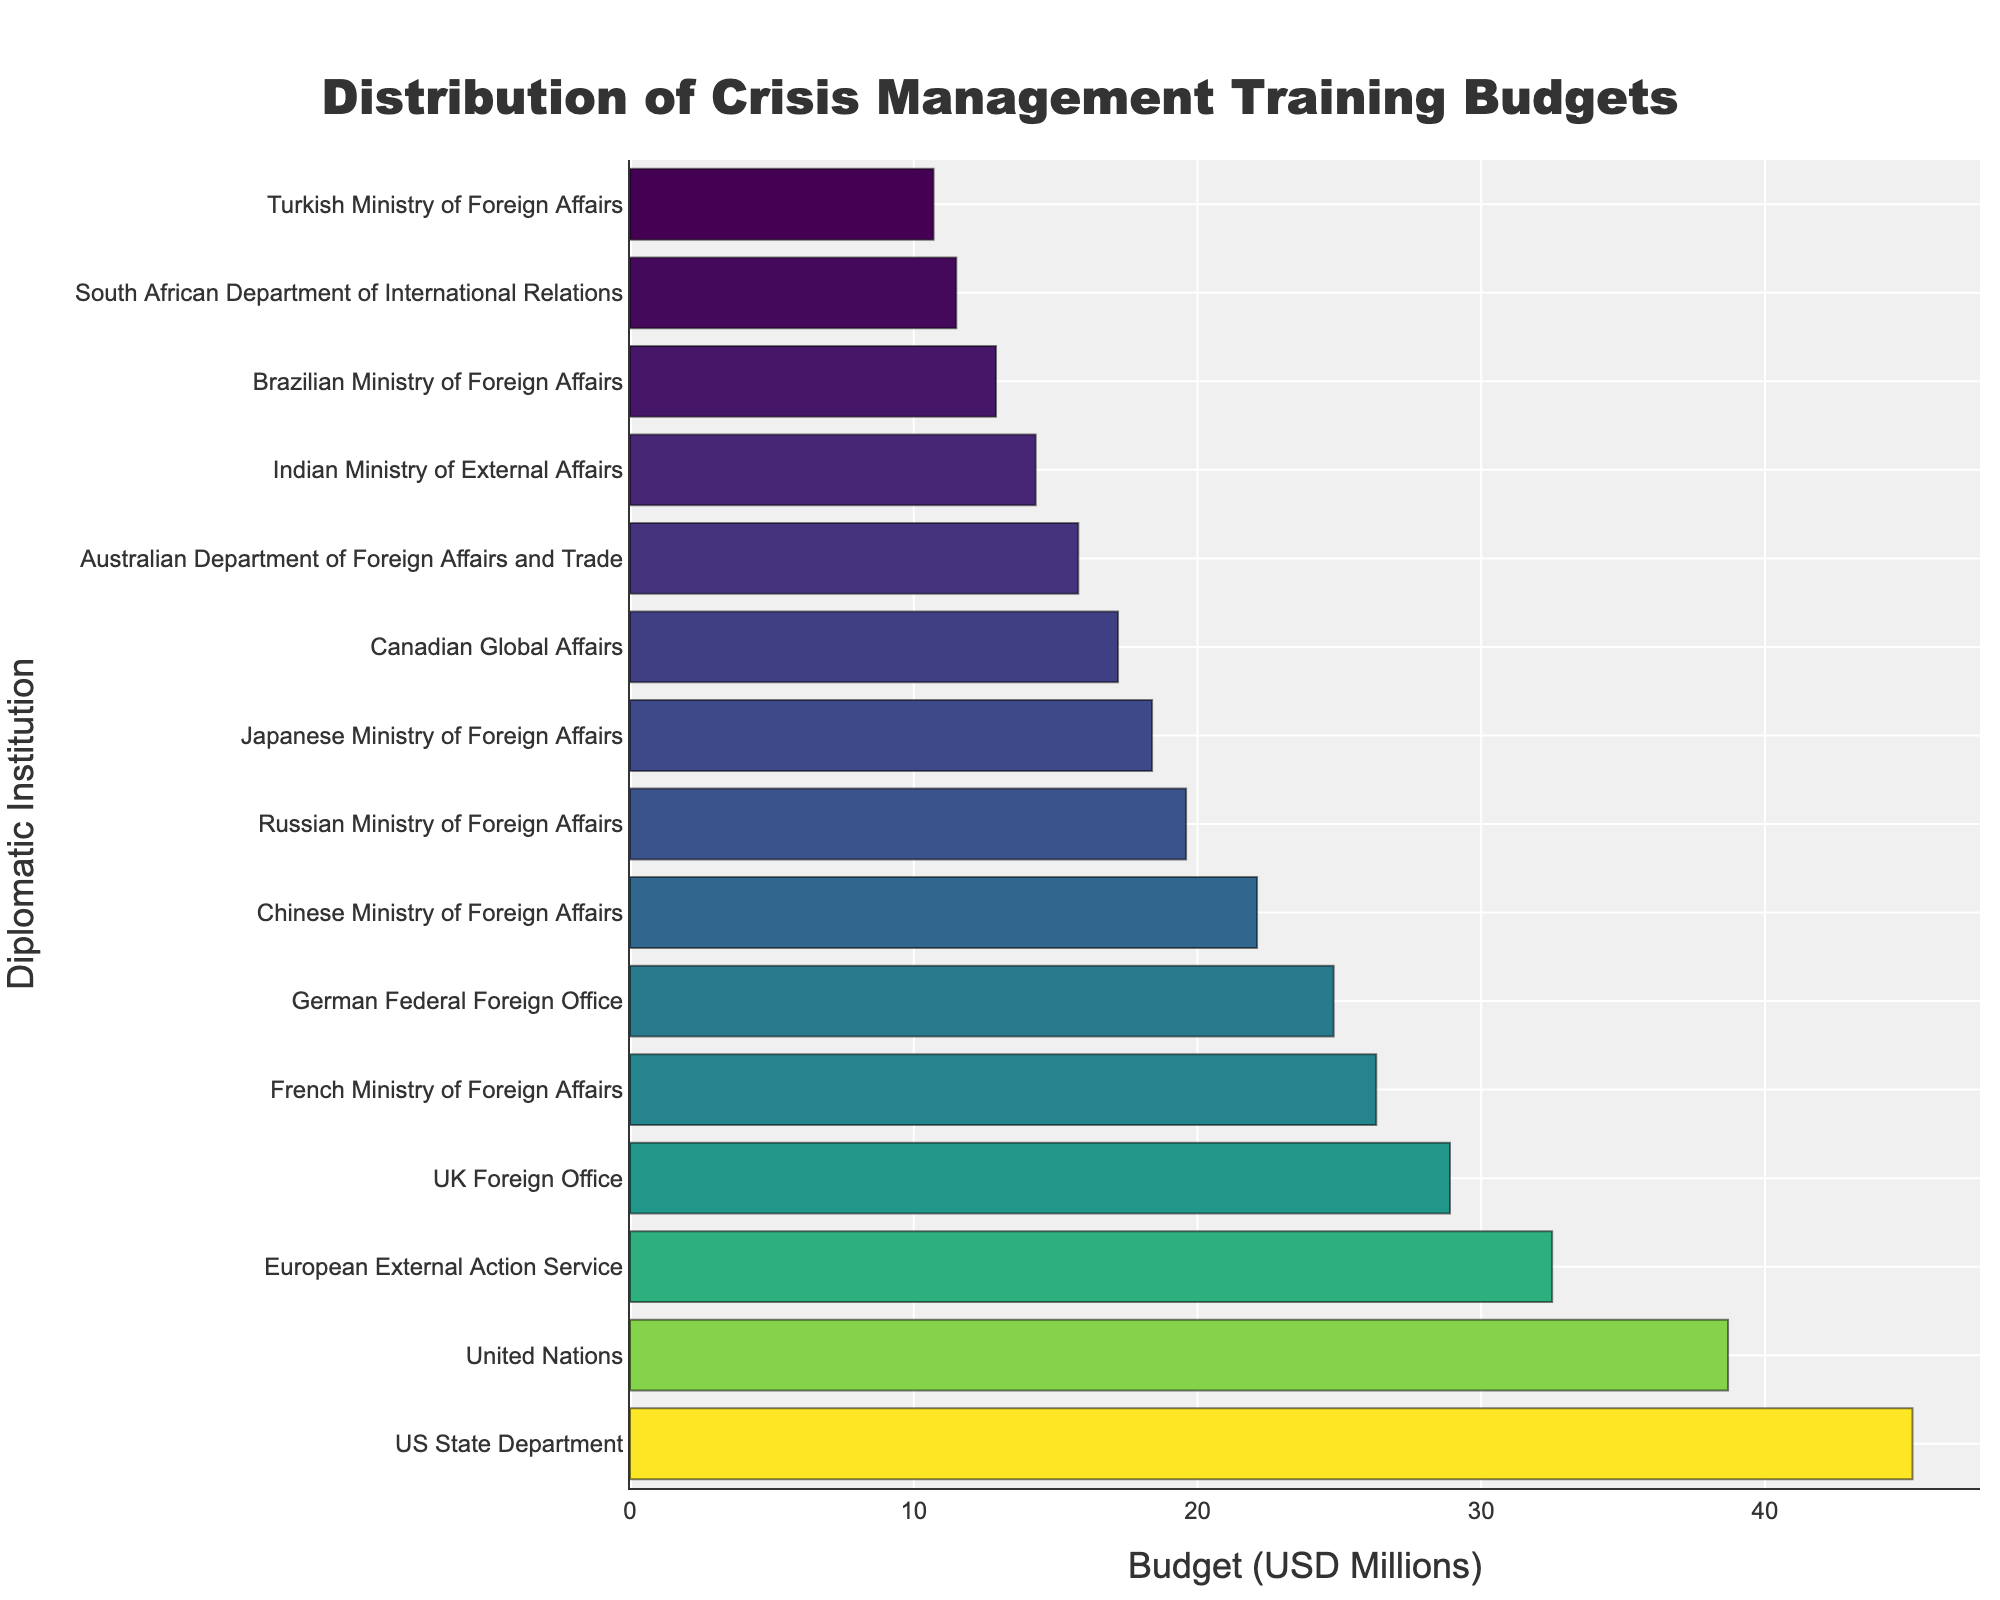What is the highest budget allocated to a diplomatic institution for crisis management training? By inspecting the lengths of the bars in the bar chart, the US State Department has the longest bar, which corresponds to the highest budget.
Answer: 45.2 million USD How much more is the budget of the US State Department compared to the UK Foreign Office? First, identify the budgets of both institutions: US State Department (45.2 million USD) and UK Foreign Office (28.9 million USD). Subtract the budget of the UK Foreign Office from the US State Department: 45.2 - 28.9 = 16.3 million USD.
Answer: 16.3 million USD Which institution has the lowest budget for crisis management training? By inspecting the lengths of the bars in the bar chart, the Turkish Ministry of Foreign Affairs has the shortest bar, corresponding to the lowest budget.
Answer: 10.7 million USD What is the total budget allocated for crisis management training across all institutions shown? Sum all budgets: 45.2 + 38.7 + 32.5 + 28.9 + 26.3 + 24.8 + 22.1 + 19.6 + 18.4 + 17.2 + 15.8 + 14.3 + 12.9 + 11.5 + 10.7 = 338.9 million USD
Answer: 338.9 million USD On average, how much budget is allocated per institution? First, calculate the total budget: 338.9 million USD. There are 15 institutions, so divide the total budget by the number of institutions: 338.9 / 15 ≈ 22.6 million USD.
Answer: 22.6 million USD Which institutions have a budget greater than 30 million USD? By inspecting the bar lengths and their corresponding values, the institutions with budgets greater than 30 million USD are the US State Department (45.2), United Nations (38.7), and European External Action Service (32.5).
Answer: US State Department, United Nations, European External Action Service How much is the combined budget of the Canadian Global Affairs and Australian Department of Foreign Affairs and Trade? Identify the budgets: Canadian Global Affairs (17.2 million USD) and Australian Department of Foreign Affairs and Trade (15.8 million USD). Sum them up: 17.2 + 15.8 = 33 million USD.
Answer: 33 million USD What is the difference in budget between the French Ministry of Foreign Affairs and the Japanese Ministry of Foreign Affairs? Identify the budgets: French Ministry of Foreign Affairs (26.3 million USD) and Japanese Ministry of Foreign Affairs (18.4 million USD). Subtract the Japanese budget from the French budget: 26.3 - 18.4 = 7.9 million USD.
Answer: 7.9 million USD Which institution has a budget closest to the average budget? The average budget per institution is approximately 22.6 million USD. By inspecting the bar lengths and their values, the German Federal Foreign Office with a budget of 24.8 million USD is the closest to the average budget.
Answer: German Federal Foreign Office What is the median budget value for the institutions? First, list the budget values in ascending order: 10.7, 11.5, 12.9, 14.3, 15.8, 17.2, 18.4, 19.6, 22.1, 24.8, 26.3, 28.9, 32.5, 38.7, 45.2. As there are 15 institutions, the median is the 8th value: 19.6 million USD.
Answer: 19.6 million USD 